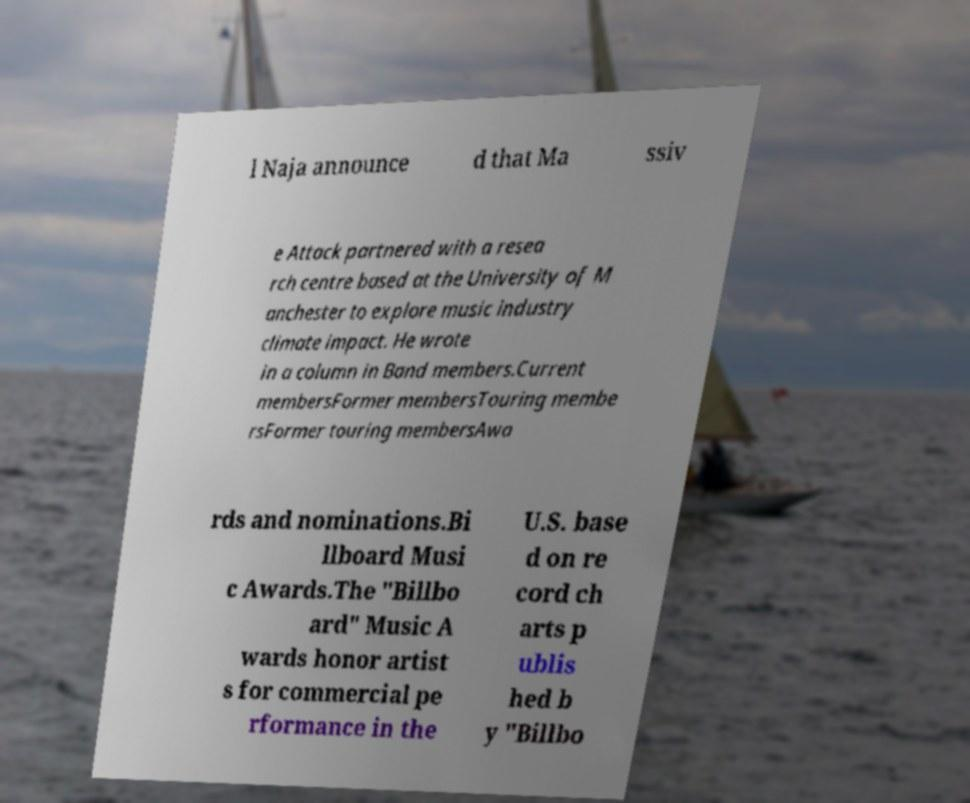Can you read and provide the text displayed in the image?This photo seems to have some interesting text. Can you extract and type it out for me? l Naja announce d that Ma ssiv e Attack partnered with a resea rch centre based at the University of M anchester to explore music industry climate impact. He wrote in a column in Band members.Current membersFormer membersTouring membe rsFormer touring membersAwa rds and nominations.Bi llboard Musi c Awards.The "Billbo ard" Music A wards honor artist s for commercial pe rformance in the U.S. base d on re cord ch arts p ublis hed b y "Billbo 